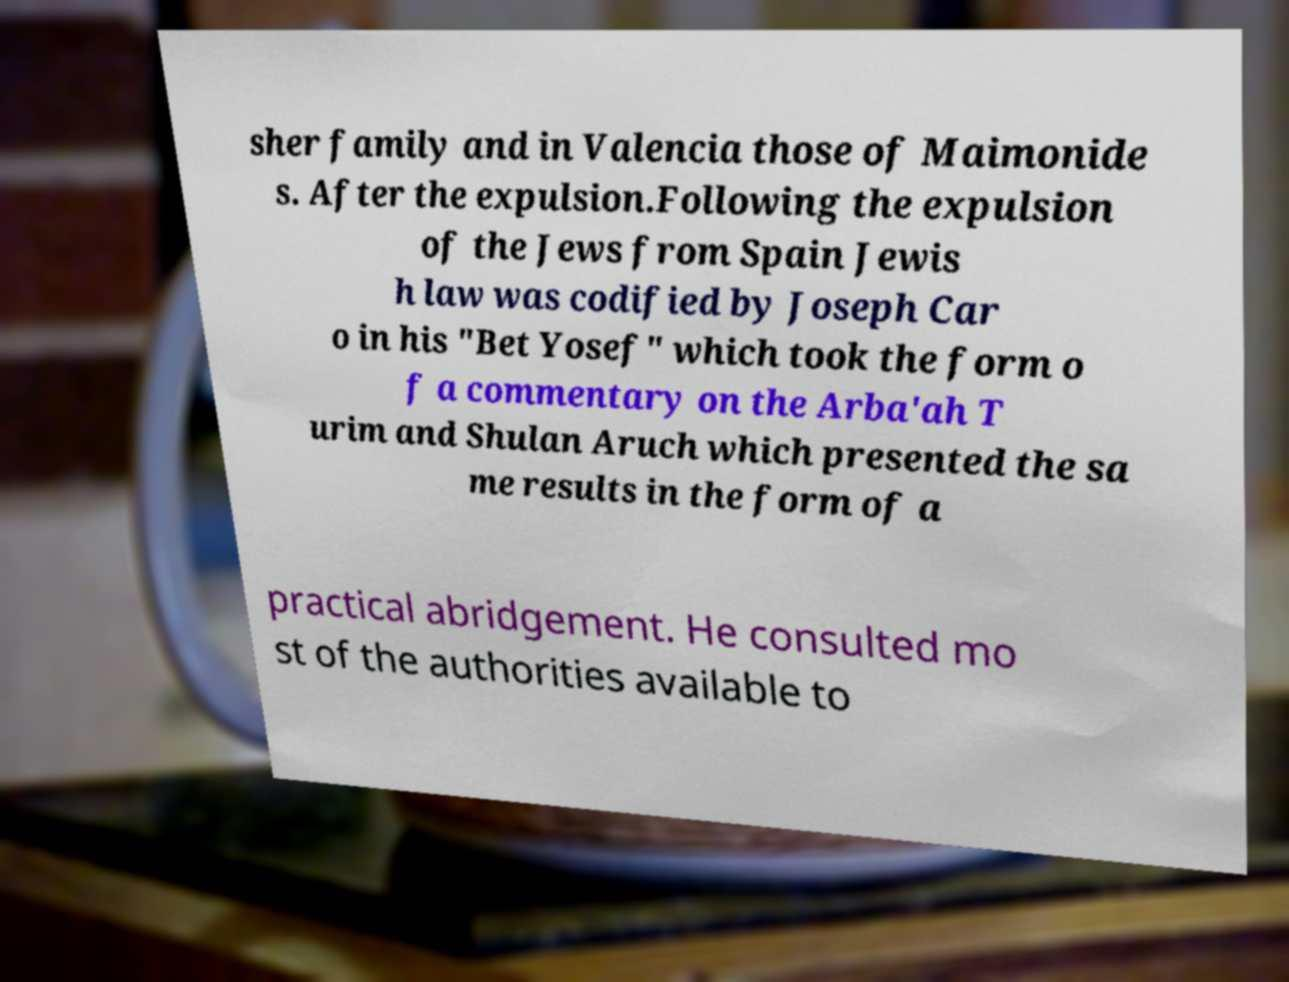Could you extract and type out the text from this image? sher family and in Valencia those of Maimonide s. After the expulsion.Following the expulsion of the Jews from Spain Jewis h law was codified by Joseph Car o in his "Bet Yosef" which took the form o f a commentary on the Arba'ah T urim and Shulan Aruch which presented the sa me results in the form of a practical abridgement. He consulted mo st of the authorities available to 